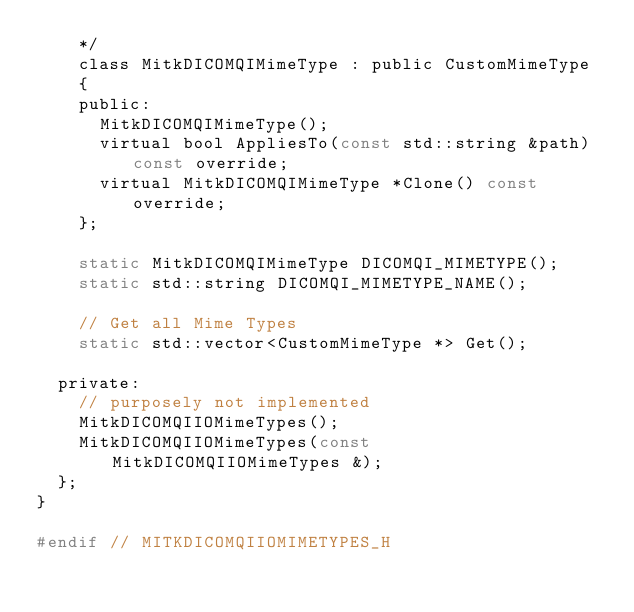Convert code to text. <code><loc_0><loc_0><loc_500><loc_500><_C_>    */
    class MitkDICOMQIMimeType : public CustomMimeType
    {
    public:
      MitkDICOMQIMimeType();
      virtual bool AppliesTo(const std::string &path) const override;
      virtual MitkDICOMQIMimeType *Clone() const override;
    };

    static MitkDICOMQIMimeType DICOMQI_MIMETYPE();
    static std::string DICOMQI_MIMETYPE_NAME();

    // Get all Mime Types
    static std::vector<CustomMimeType *> Get();

  private:
    // purposely not implemented
    MitkDICOMQIIOMimeTypes();
    MitkDICOMQIIOMimeTypes(const MitkDICOMQIIOMimeTypes &);
  };
}

#endif // MITKDICOMQIIOMIMETYPES_H
</code> 